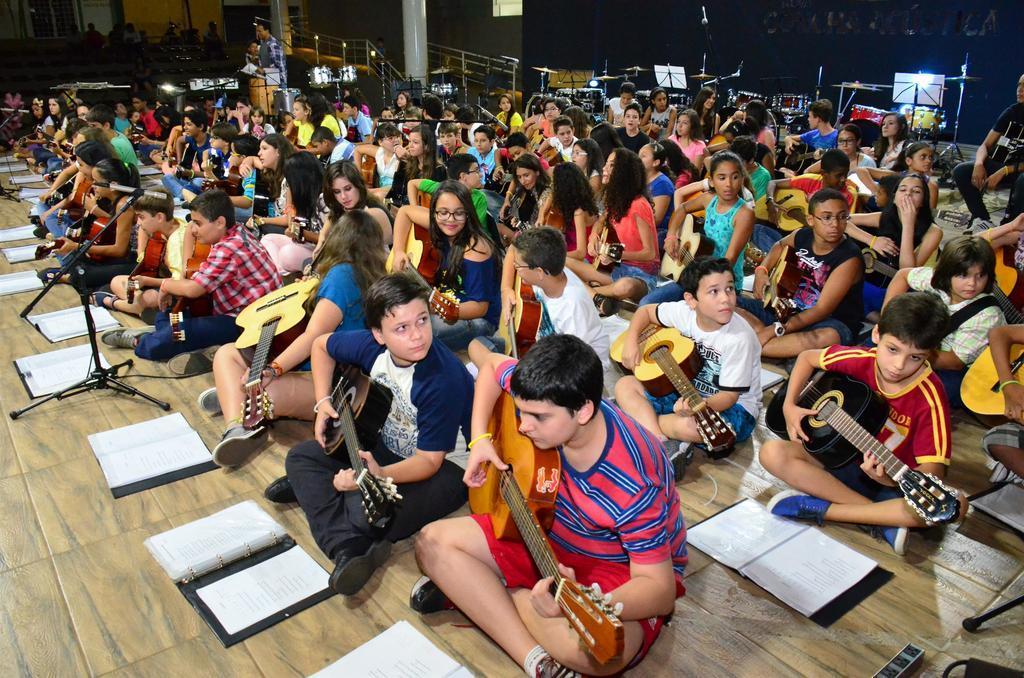Please provide a concise description of this image. In this picture we can see a group of children's sitting on floor holding guitars in their hands and in front of them there are books and here we can see mic and in background we can see some person is standing, fence, wall. 